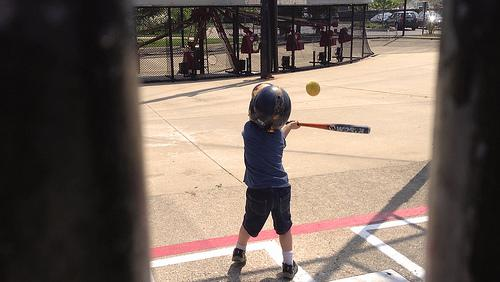Question: why is the boy holding the bat?
Choices:
A. He is protecting himself from robbers.
B. He is playing basketball.
C. He is trying to hit the ball.
D. He is selling bats to tourists.
Answer with the letter. Answer: C Question: how many people are there?
Choices:
A. One.
B. Two.
C. Three.
D. Four.
Answer with the letter. Answer: A Question: where is the boy standing?
Choices:
A. On the field.
B. On the beach.
C. In a batting cage.
D. On the street.
Answer with the letter. Answer: C Question: who is standing in the photo?
Choices:
A. A boy.
B. A girl.
C. A man.
D. A woman.
Answer with the letter. Answer: A Question: when will the boy leave the batting cage?
Choices:
A. After he has finished hitting the balls.
B. When it starts to rain.
C. When the bell rings.
D. When it gets dark.
Answer with the letter. Answer: A 